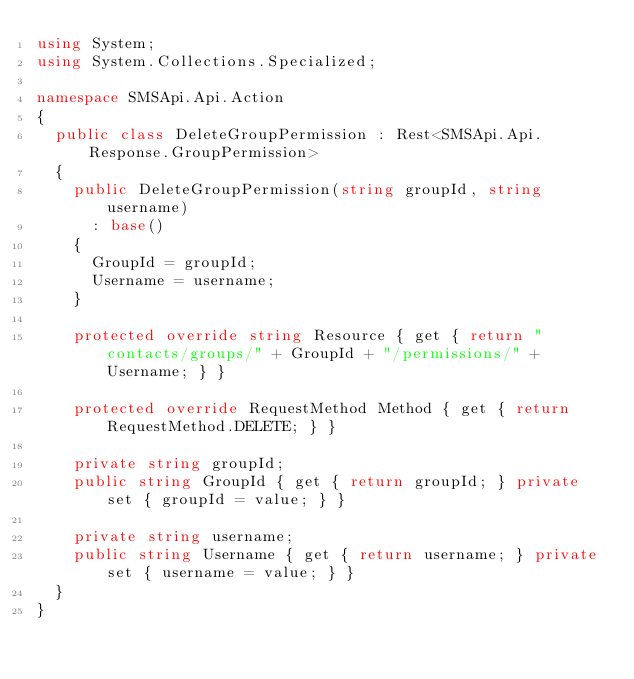Convert code to text. <code><loc_0><loc_0><loc_500><loc_500><_C#_>using System;
using System.Collections.Specialized;

namespace SMSApi.Api.Action
{
	public class DeleteGroupPermission : Rest<SMSApi.Api.Response.GroupPermission>
	{
		public DeleteGroupPermission(string groupId, string username)
			: base()
		{
			GroupId = groupId;
			Username = username;
		}

		protected override string Resource { get { return "contacts/groups/" + GroupId + "/permissions/" + Username; } }

		protected override RequestMethod Method { get { return RequestMethod.DELETE; } }

		private string groupId;
		public string GroupId { get { return groupId; } private set { groupId = value; } }

		private string username;
		public string Username { get { return username; } private set { username = value; } }
	}
}
</code> 